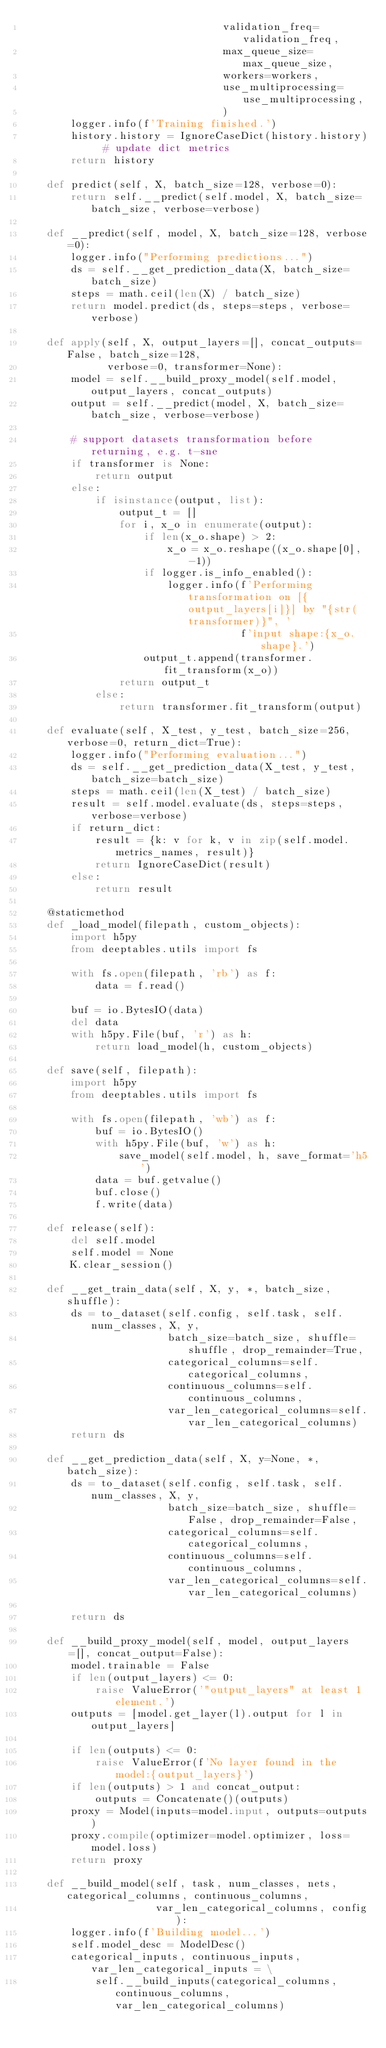<code> <loc_0><loc_0><loc_500><loc_500><_Python_>                                 validation_freq=validation_freq,
                                 max_queue_size=max_queue_size,
                                 workers=workers,
                                 use_multiprocessing=use_multiprocessing,
                                 )
        logger.info(f'Training finished.')
        history.history = IgnoreCaseDict(history.history)  # update dict metrics
        return history

    def predict(self, X, batch_size=128, verbose=0):
        return self.__predict(self.model, X, batch_size=batch_size, verbose=verbose)

    def __predict(self, model, X, batch_size=128, verbose=0):
        logger.info("Performing predictions...")
        ds = self.__get_prediction_data(X, batch_size=batch_size)
        steps = math.ceil(len(X) / batch_size)
        return model.predict(ds, steps=steps, verbose=verbose)

    def apply(self, X, output_layers=[], concat_outputs=False, batch_size=128,
              verbose=0, transformer=None):
        model = self.__build_proxy_model(self.model, output_layers, concat_outputs)
        output = self.__predict(model, X, batch_size=batch_size, verbose=verbose)

        # support datasets transformation before returning, e.g. t-sne
        if transformer is None:
            return output
        else:
            if isinstance(output, list):
                output_t = []
                for i, x_o in enumerate(output):
                    if len(x_o.shape) > 2:
                        x_o = x_o.reshape((x_o.shape[0], -1))
                    if logger.is_info_enabled():
                        logger.info(f'Performing transformation on [{output_layers[i]}] by "{str(transformer)}", '
                                    f'input shape:{x_o.shape}.')
                    output_t.append(transformer.fit_transform(x_o))
                return output_t
            else:
                return transformer.fit_transform(output)

    def evaluate(self, X_test, y_test, batch_size=256, verbose=0, return_dict=True):
        logger.info("Performing evaluation...")
        ds = self.__get_prediction_data(X_test, y_test, batch_size=batch_size)
        steps = math.ceil(len(X_test) / batch_size)
        result = self.model.evaluate(ds, steps=steps, verbose=verbose)
        if return_dict:
            result = {k: v for k, v in zip(self.model.metrics_names, result)}
            return IgnoreCaseDict(result)
        else:
            return result

    @staticmethod
    def _load_model(filepath, custom_objects):
        import h5py
        from deeptables.utils import fs

        with fs.open(filepath, 'rb') as f:
            data = f.read()

        buf = io.BytesIO(data)
        del data
        with h5py.File(buf, 'r') as h:
            return load_model(h, custom_objects)

    def save(self, filepath):
        import h5py
        from deeptables.utils import fs

        with fs.open(filepath, 'wb') as f:
            buf = io.BytesIO()
            with h5py.File(buf, 'w') as h:
                save_model(self.model, h, save_format='h5')
            data = buf.getvalue()
            buf.close()
            f.write(data)

    def release(self):
        del self.model
        self.model = None
        K.clear_session()

    def __get_train_data(self, X, y, *, batch_size, shuffle):
        ds = to_dataset(self.config, self.task, self.num_classes, X, y,
                        batch_size=batch_size, shuffle=shuffle, drop_remainder=True,
                        categorical_columns=self.categorical_columns,
                        continuous_columns=self.continuous_columns,
                        var_len_categorical_columns=self.var_len_categorical_columns)
        return ds

    def __get_prediction_data(self, X, y=None, *, batch_size):
        ds = to_dataset(self.config, self.task, self.num_classes, X, y,
                        batch_size=batch_size, shuffle=False, drop_remainder=False,
                        categorical_columns=self.categorical_columns,
                        continuous_columns=self.continuous_columns,
                        var_len_categorical_columns=self.var_len_categorical_columns)

        return ds

    def __build_proxy_model(self, model, output_layers=[], concat_output=False):
        model.trainable = False
        if len(output_layers) <= 0:
            raise ValueError('"output_layers" at least 1 element.')
        outputs = [model.get_layer(l).output for l in output_layers]

        if len(outputs) <= 0:
            raise ValueError(f'No layer found in the model:{output_layers}')
        if len(outputs) > 1 and concat_output:
            outputs = Concatenate()(outputs)
        proxy = Model(inputs=model.input, outputs=outputs)
        proxy.compile(optimizer=model.optimizer, loss=model.loss)
        return proxy

    def __build_model(self, task, num_classes, nets, categorical_columns, continuous_columns,
                      var_len_categorical_columns, config):
        logger.info(f'Building model...')
        self.model_desc = ModelDesc()
        categorical_inputs, continuous_inputs, var_len_categorical_inputs = \
            self.__build_inputs(categorical_columns, continuous_columns, var_len_categorical_columns)</code> 